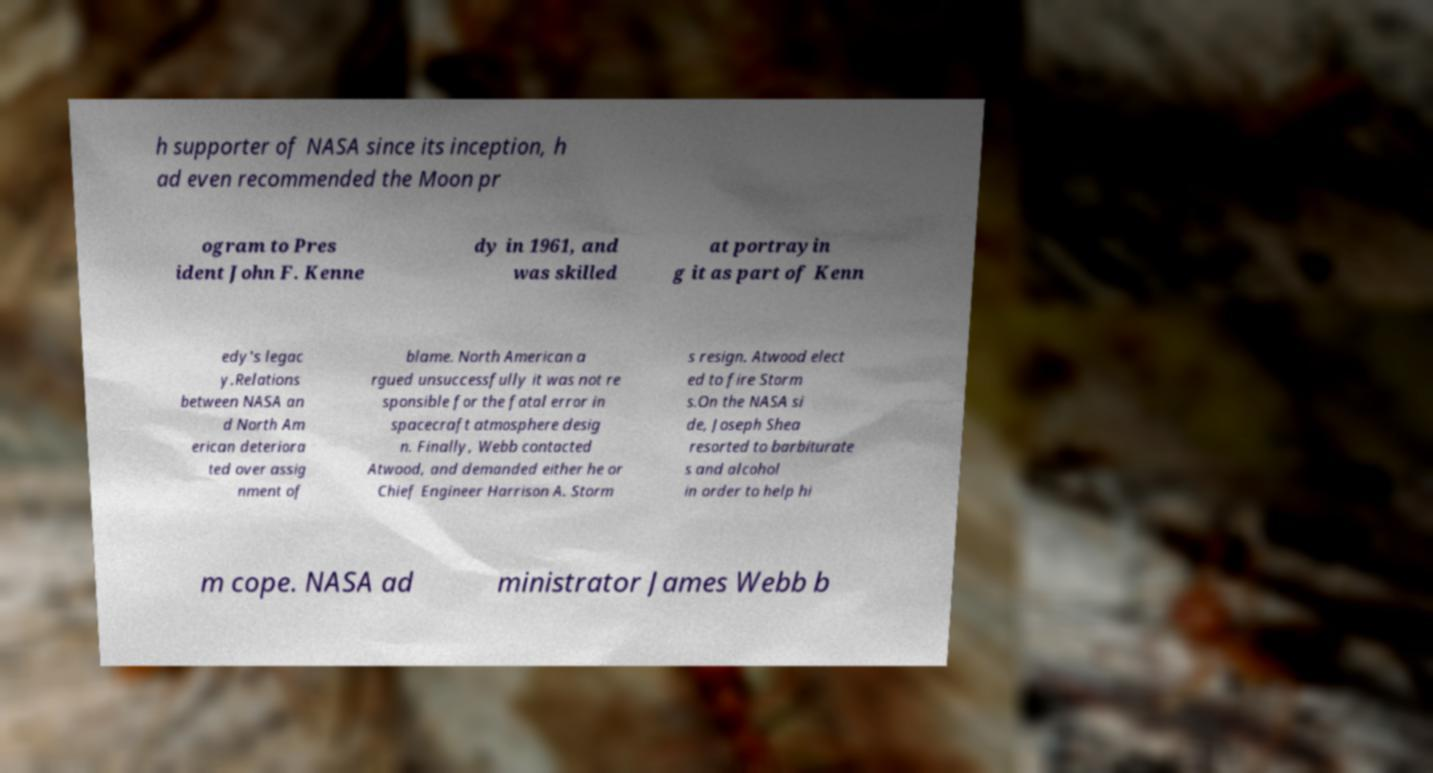I need the written content from this picture converted into text. Can you do that? h supporter of NASA since its inception, h ad even recommended the Moon pr ogram to Pres ident John F. Kenne dy in 1961, and was skilled at portrayin g it as part of Kenn edy's legac y.Relations between NASA an d North Am erican deteriora ted over assig nment of blame. North American a rgued unsuccessfully it was not re sponsible for the fatal error in spacecraft atmosphere desig n. Finally, Webb contacted Atwood, and demanded either he or Chief Engineer Harrison A. Storm s resign. Atwood elect ed to fire Storm s.On the NASA si de, Joseph Shea resorted to barbiturate s and alcohol in order to help hi m cope. NASA ad ministrator James Webb b 